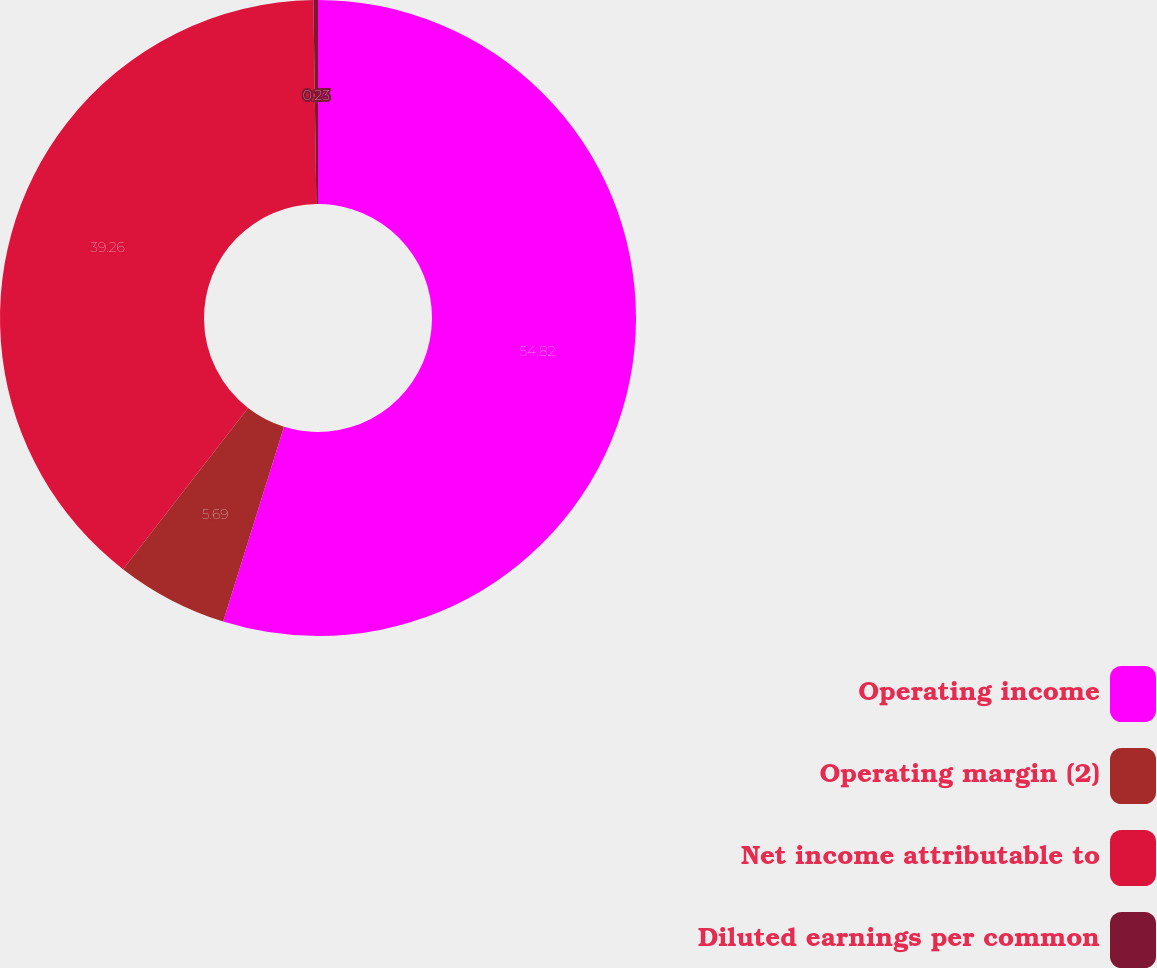<chart> <loc_0><loc_0><loc_500><loc_500><pie_chart><fcel>Operating income<fcel>Operating margin (2)<fcel>Net income attributable to<fcel>Diluted earnings per common<nl><fcel>54.82%<fcel>5.69%<fcel>39.26%<fcel>0.23%<nl></chart> 